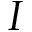Convert formula to latex. <formula><loc_0><loc_0><loc_500><loc_500>I</formula> 